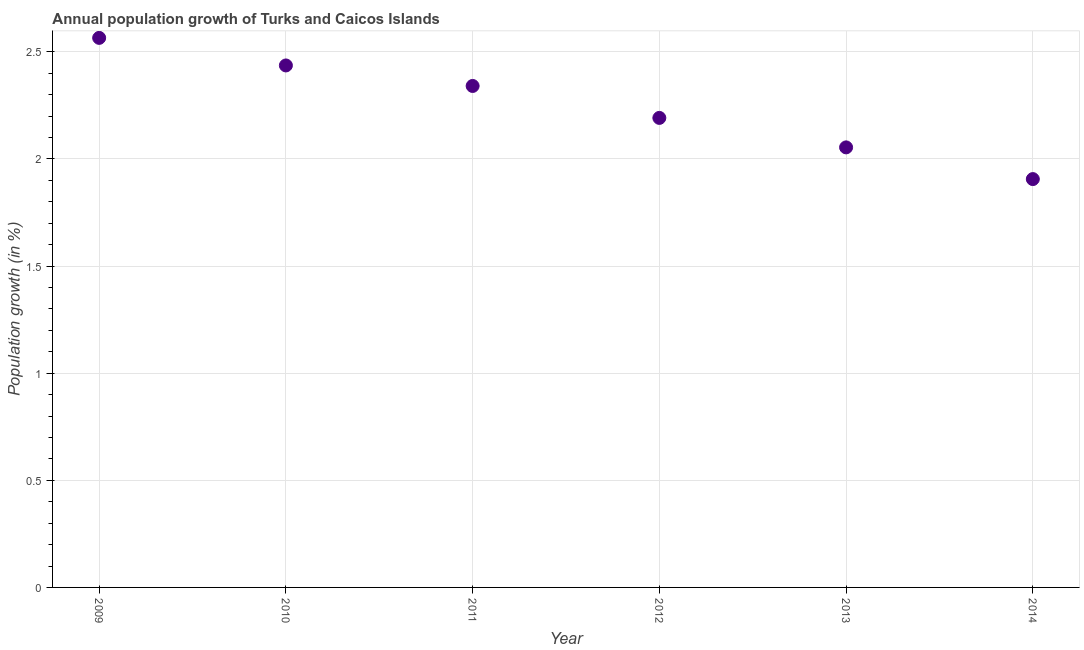What is the population growth in 2009?
Offer a very short reply. 2.57. Across all years, what is the maximum population growth?
Your response must be concise. 2.57. Across all years, what is the minimum population growth?
Keep it short and to the point. 1.91. What is the sum of the population growth?
Your answer should be compact. 13.49. What is the difference between the population growth in 2011 and 2014?
Give a very brief answer. 0.43. What is the average population growth per year?
Your answer should be compact. 2.25. What is the median population growth?
Your answer should be very brief. 2.27. What is the ratio of the population growth in 2013 to that in 2014?
Make the answer very short. 1.08. Is the population growth in 2010 less than that in 2013?
Provide a short and direct response. No. Is the difference between the population growth in 2009 and 2013 greater than the difference between any two years?
Your answer should be compact. No. What is the difference between the highest and the second highest population growth?
Your answer should be compact. 0.13. Is the sum of the population growth in 2009 and 2011 greater than the maximum population growth across all years?
Provide a short and direct response. Yes. What is the difference between the highest and the lowest population growth?
Keep it short and to the point. 0.66. Does the population growth monotonically increase over the years?
Make the answer very short. No. How many years are there in the graph?
Offer a terse response. 6. What is the difference between two consecutive major ticks on the Y-axis?
Offer a very short reply. 0.5. Are the values on the major ticks of Y-axis written in scientific E-notation?
Your answer should be compact. No. Does the graph contain any zero values?
Keep it short and to the point. No. What is the title of the graph?
Offer a very short reply. Annual population growth of Turks and Caicos Islands. What is the label or title of the X-axis?
Give a very brief answer. Year. What is the label or title of the Y-axis?
Provide a short and direct response. Population growth (in %). What is the Population growth (in %) in 2009?
Your response must be concise. 2.57. What is the Population growth (in %) in 2010?
Keep it short and to the point. 2.44. What is the Population growth (in %) in 2011?
Provide a succinct answer. 2.34. What is the Population growth (in %) in 2012?
Your answer should be very brief. 2.19. What is the Population growth (in %) in 2013?
Your answer should be compact. 2.05. What is the Population growth (in %) in 2014?
Ensure brevity in your answer.  1.91. What is the difference between the Population growth (in %) in 2009 and 2010?
Give a very brief answer. 0.13. What is the difference between the Population growth (in %) in 2009 and 2011?
Provide a short and direct response. 0.22. What is the difference between the Population growth (in %) in 2009 and 2012?
Offer a terse response. 0.37. What is the difference between the Population growth (in %) in 2009 and 2013?
Ensure brevity in your answer.  0.51. What is the difference between the Population growth (in %) in 2009 and 2014?
Your answer should be very brief. 0.66. What is the difference between the Population growth (in %) in 2010 and 2011?
Provide a succinct answer. 0.1. What is the difference between the Population growth (in %) in 2010 and 2012?
Your answer should be compact. 0.24. What is the difference between the Population growth (in %) in 2010 and 2013?
Ensure brevity in your answer.  0.38. What is the difference between the Population growth (in %) in 2010 and 2014?
Your answer should be very brief. 0.53. What is the difference between the Population growth (in %) in 2011 and 2012?
Provide a succinct answer. 0.15. What is the difference between the Population growth (in %) in 2011 and 2013?
Offer a very short reply. 0.29. What is the difference between the Population growth (in %) in 2011 and 2014?
Your answer should be compact. 0.43. What is the difference between the Population growth (in %) in 2012 and 2013?
Ensure brevity in your answer.  0.14. What is the difference between the Population growth (in %) in 2012 and 2014?
Ensure brevity in your answer.  0.29. What is the difference between the Population growth (in %) in 2013 and 2014?
Make the answer very short. 0.15. What is the ratio of the Population growth (in %) in 2009 to that in 2010?
Provide a succinct answer. 1.05. What is the ratio of the Population growth (in %) in 2009 to that in 2011?
Your answer should be very brief. 1.1. What is the ratio of the Population growth (in %) in 2009 to that in 2012?
Give a very brief answer. 1.17. What is the ratio of the Population growth (in %) in 2009 to that in 2013?
Offer a terse response. 1.25. What is the ratio of the Population growth (in %) in 2009 to that in 2014?
Make the answer very short. 1.35. What is the ratio of the Population growth (in %) in 2010 to that in 2011?
Make the answer very short. 1.04. What is the ratio of the Population growth (in %) in 2010 to that in 2012?
Your answer should be very brief. 1.11. What is the ratio of the Population growth (in %) in 2010 to that in 2013?
Ensure brevity in your answer.  1.19. What is the ratio of the Population growth (in %) in 2010 to that in 2014?
Your answer should be very brief. 1.28. What is the ratio of the Population growth (in %) in 2011 to that in 2012?
Provide a short and direct response. 1.07. What is the ratio of the Population growth (in %) in 2011 to that in 2013?
Provide a succinct answer. 1.14. What is the ratio of the Population growth (in %) in 2011 to that in 2014?
Offer a terse response. 1.23. What is the ratio of the Population growth (in %) in 2012 to that in 2013?
Give a very brief answer. 1.07. What is the ratio of the Population growth (in %) in 2012 to that in 2014?
Make the answer very short. 1.15. What is the ratio of the Population growth (in %) in 2013 to that in 2014?
Provide a succinct answer. 1.08. 